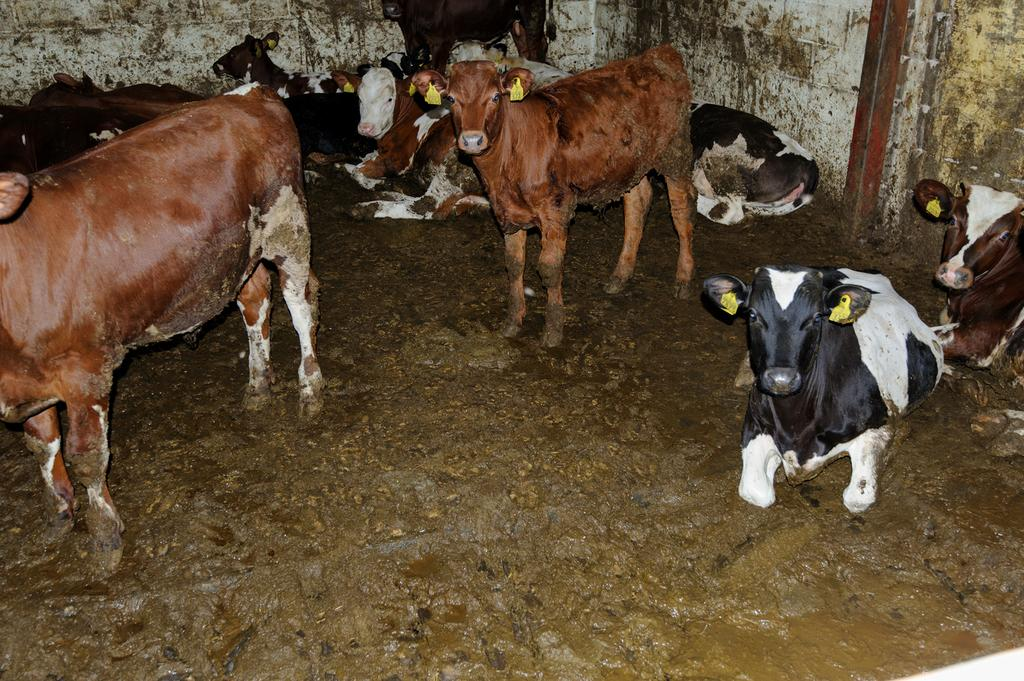What animals are present in the image? There is a group of cows in the image. What are the cows doing in the image? Some cows are sitting, while others are standing. What can be seen behind the cows in the image? There is a wall behind the cows. What type of berry can be seen growing on the wall behind the cows? There are no berries visible on the wall behind the cows in the image. 